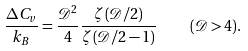<formula> <loc_0><loc_0><loc_500><loc_500>\frac { \Delta C _ { v } } { k _ { B } } = \frac { \mathcal { D } ^ { 2 } } { 4 } \frac { \zeta \left ( \mathcal { D } / 2 \right ) } { \zeta \left ( \mathcal { D } / 2 - 1 \right ) } \quad ( \mathcal { D } > 4 ) .</formula> 